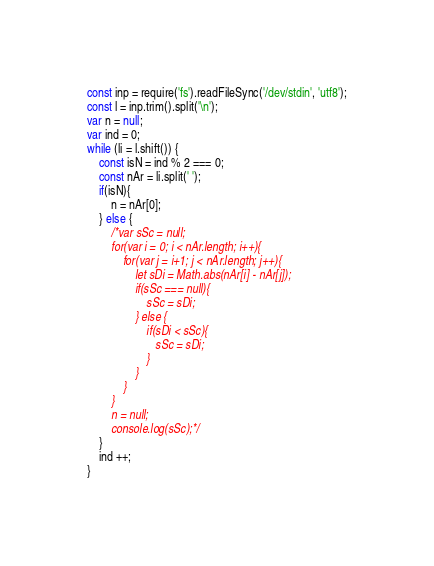Convert code to text. <code><loc_0><loc_0><loc_500><loc_500><_JavaScript_>const inp = require('fs').readFileSync('/dev/stdin', 'utf8');
const l = inp.trim().split('\n');
var n = null;
var ind = 0;
while (li = l.shift()) {
    const isN = ind % 2 === 0;
    const nAr = li.split(' ');
    if(isN){
        n = nAr[0];
    } else {
        /*var sSc = null;
        for(var i = 0; i < nAr.length; i++){
            for(var j = i+1; j < nAr.length; j++){
                let sDi = Math.abs(nAr[i] - nAr[j]);
                if(sSc === null){
                    sSc = sDi;
                } else {
                    if(sDi < sSc){
                       sSc = sDi; 
                    }
                }
            }
        }
        n = null;
        console.log(sSc);*/
    }
    ind ++;
} 
</code> 